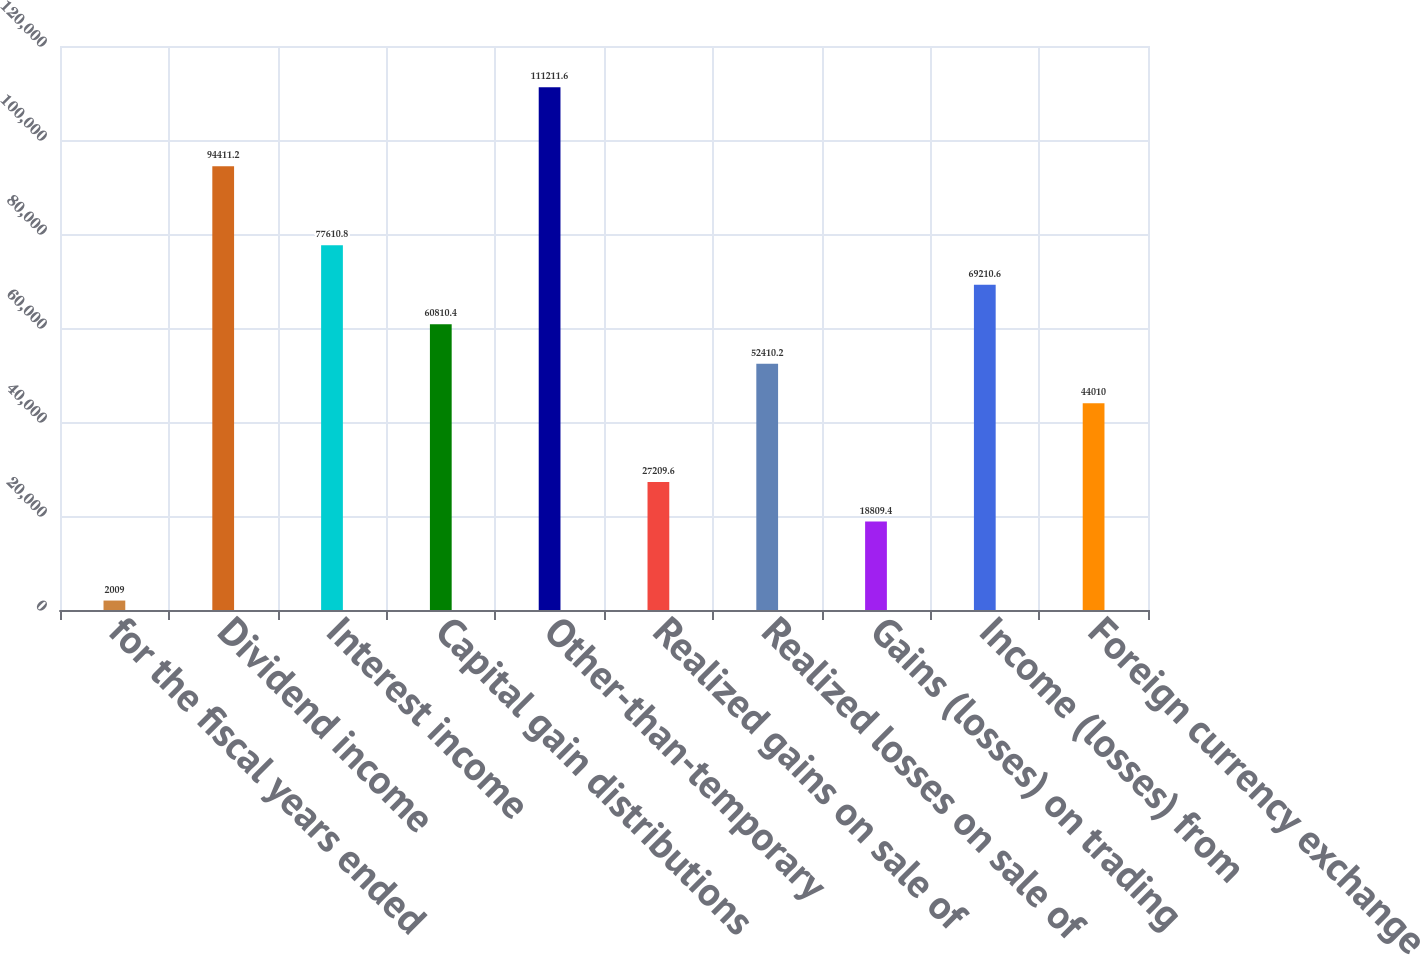Convert chart. <chart><loc_0><loc_0><loc_500><loc_500><bar_chart><fcel>for the fiscal years ended<fcel>Dividend income<fcel>Interest income<fcel>Capital gain distributions<fcel>Other-than-temporary<fcel>Realized gains on sale of<fcel>Realized losses on sale of<fcel>Gains (losses) on trading<fcel>Income (losses) from<fcel>Foreign currency exchange<nl><fcel>2009<fcel>94411.2<fcel>77610.8<fcel>60810.4<fcel>111212<fcel>27209.6<fcel>52410.2<fcel>18809.4<fcel>69210.6<fcel>44010<nl></chart> 